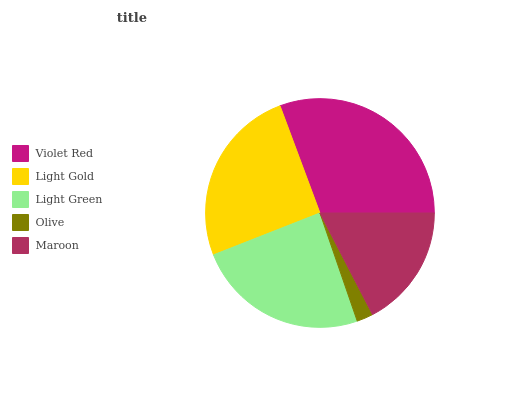Is Olive the minimum?
Answer yes or no. Yes. Is Violet Red the maximum?
Answer yes or no. Yes. Is Light Gold the minimum?
Answer yes or no. No. Is Light Gold the maximum?
Answer yes or no. No. Is Violet Red greater than Light Gold?
Answer yes or no. Yes. Is Light Gold less than Violet Red?
Answer yes or no. Yes. Is Light Gold greater than Violet Red?
Answer yes or no. No. Is Violet Red less than Light Gold?
Answer yes or no. No. Is Light Green the high median?
Answer yes or no. Yes. Is Light Green the low median?
Answer yes or no. Yes. Is Maroon the high median?
Answer yes or no. No. Is Light Gold the low median?
Answer yes or no. No. 